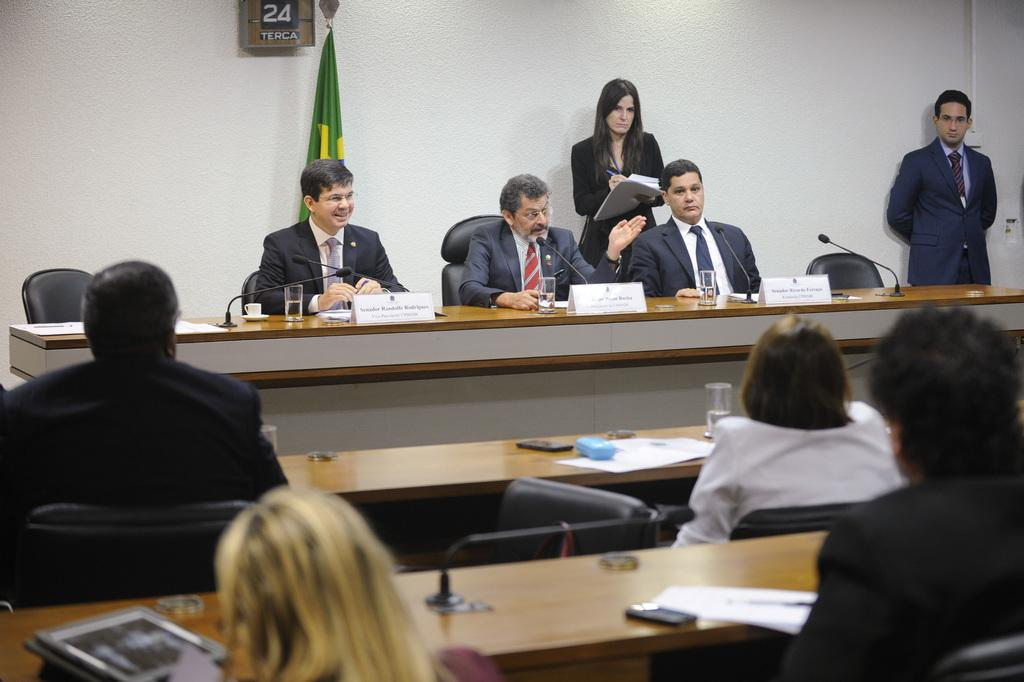What are the people in the image doing? The people in the image are sitting on chairs. Can you describe the activity of one of the people in the image? Yes, a person is speaking on a microphone in the image. What memory is being shared by the person speaking on the microphone in the image? There is no indication in the image of a specific memory being shared by the person speaking on the microphone. 